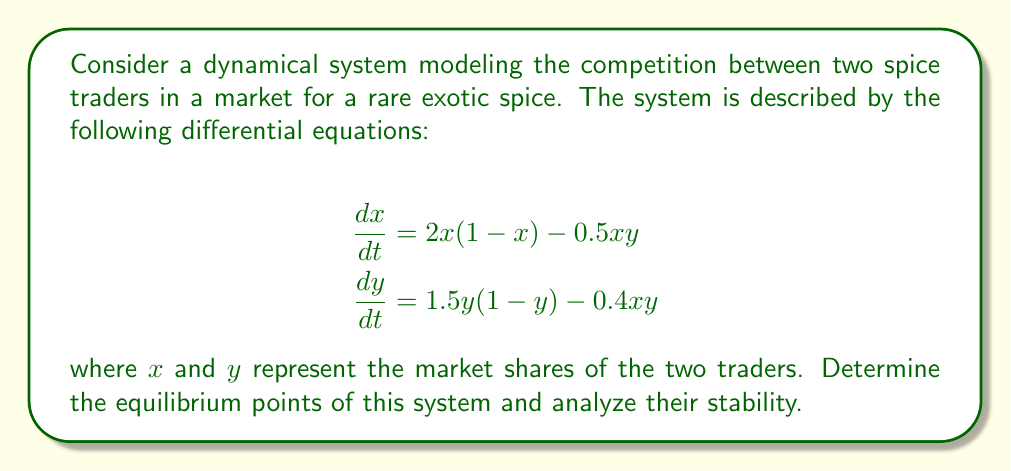Show me your answer to this math problem. 1. Find the equilibrium points by setting $\frac{dx}{dt} = 0$ and $\frac{dy}{dt} = 0$:

   $$\begin{align}
   2x(1-x) - 0.5xy &= 0 \\
   1.5y(1-y) - 0.4xy &= 0
   \end{align}$$

2. Solve the system of equations:
   a) Trivial equilibrium: $(0,0)$
   b) Boundary equilibria: $(1,0)$ and $(0,1)$
   c) Interior equilibrium: Solve simultaneously
      $$\begin{align}
      2-2x-0.5y &= 0 \\
      1.5-1.5y-0.4x &= 0
      \end{align}$$
      This yields $(x^*, y^*) = (0.6, 0.8)$

3. Analyze stability using the Jacobian matrix:
   $$J = \begin{bmatrix}
   2-4x-0.5y & -0.5x \\
   -0.4y & 1.5-3y-0.4x
   \end{bmatrix}$$

4. Evaluate Jacobian at each equilibrium point:
   a) At $(0,0)$: $J(0,0) = \begin{bmatrix} 2 & 0 \\ 0 & 1.5 \end{bmatrix}$
      Eigenvalues: $\lambda_1 = 2$, $\lambda_2 = 1.5$ (unstable)
   
   b) At $(1,0)$: $J(1,0) = \begin{bmatrix} -2 & -0.5 \\ 0 & 1.1 \end{bmatrix}$
      Eigenvalues: $\lambda_1 = -2$, $\lambda_2 = 1.1$ (unstable)
   
   c) At $(0,1)$: $J(0,1) = \begin{bmatrix} 1.5 & 0 \\ -0.4 & -1.5 \end{bmatrix}$
      Eigenvalues: $\lambda_1 = 1.5$, $\lambda_2 = -1.5$ (unstable)
   
   d) At $(0.6, 0.8)$: $J(0.6,0.8) = \begin{bmatrix} -0.7 & -0.3 \\ -0.32 & -0.99 \end{bmatrix}$
      Eigenvalues: $\lambda_1 \approx -0.47$, $\lambda_2 \approx -1.22$ (stable)

5. Conclusion: The interior equilibrium $(0.6, 0.8)$ is the only stable equilibrium point.
Answer: The system has four equilibrium points: $(0,0)$, $(1,0)$, $(0,1)$, and $(0.6,0.8)$. Only the interior equilibrium $(0.6,0.8)$ is stable. 